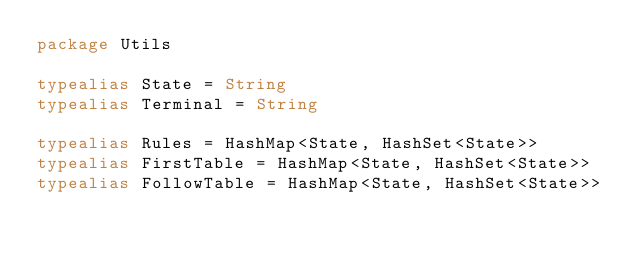Convert code to text. <code><loc_0><loc_0><loc_500><loc_500><_Kotlin_>package Utils

typealias State = String
typealias Terminal = String

typealias Rules = HashMap<State, HashSet<State>>
typealias FirstTable = HashMap<State, HashSet<State>>
typealias FollowTable = HashMap<State, HashSet<State>>
</code> 